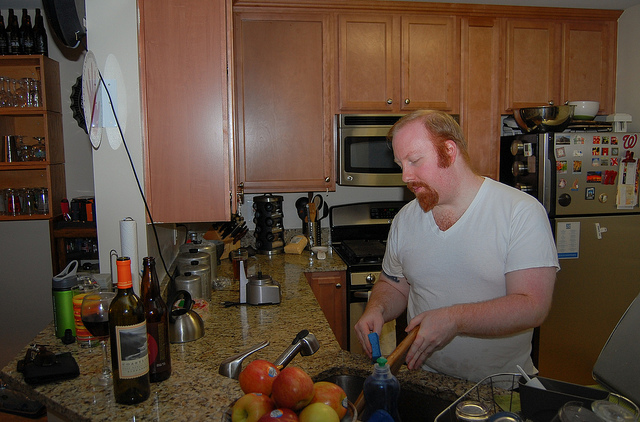<image>What fruit is he cutting? The person is not cutting any fruit in the image. However, it could be an apple. What color is the dogs dish? There is no dog dish in the image. However, it could be silver, blue or green. How is the pattern on his shirt? I am not sure about the pattern on his shirt. It can be either plain or solid. What brand of beer do you see? There is no beer in the image. Is the beer bottle half empty? I am not sure if the beer bottle is half empty. It is both yes and no. What kind of classic wine is listed on the advertisement about the wine dispenser? I am not sure about the kind of classic wine listed on the advertisement about the wine dispenser. It can be 'barefoot', 'red' or 'merlot'. What kind of controller is she holding? It is unclear what she is holding. It could be a sponge, scrubber, remote, or nothing. What brand is the juice? There is no juice in the image. But it can be 'naked juice', 'v8', 'minute maid' or 'apple'. What color is the dogs dish? I don't know what color the dog's dish is. I cannot see it in the image. What fruit is he cutting? It is uncertain what fruit he is cutting. It can be seen as an apple, but there is also a possibility that there is no fruit. How is the pattern on his shirt? I don't know how is the pattern on his shirt. It can be plain or solid. What brand of beer do you see? There is no beer brand visible in the image. What brand is the juice? It is ambiguous what brand is the juice. It can be 'naked juice', 'v8', 'minute maid' or 'apple'. Is the beer bottle half empty? I don't know if the beer bottle is half empty. It can be both half empty or not. What kind of controller is she holding? It is ambiguous what kind of controller she is holding. It can be seen as 'sponge', 'scrubber' or 'remote'. What kind of classic wine is listed on the advertisement about the wine dispenser? I don't know what kind of classic wine is listed on the advertisement about the wine dispenser. It can be 'barefoot', 'red', 'none shown', or 'merlot'. 